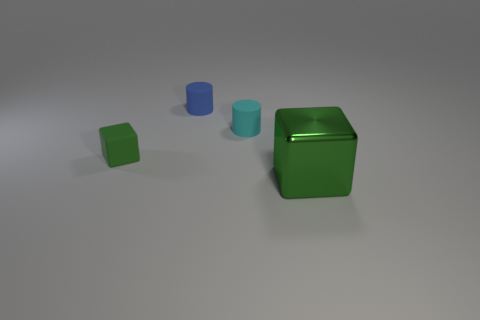There is a metallic object; is its color the same as the rubber cylinder that is on the left side of the tiny cyan cylinder?
Your response must be concise. No. What shape is the matte object in front of the cyan rubber cylinder?
Keep it short and to the point. Cube. How many other objects are there of the same material as the tiny green cube?
Your answer should be compact. 2. What material is the cyan cylinder?
Your answer should be very brief. Rubber. What number of small objects are green cubes or rubber cubes?
Provide a short and direct response. 1. What number of metallic cubes are behind the tiny green rubber cube?
Offer a terse response. 0. Are there any big matte things of the same color as the big block?
Give a very brief answer. No. What shape is the green matte object that is the same size as the cyan cylinder?
Give a very brief answer. Cube. What number of green objects are metal cylinders or tiny things?
Provide a succinct answer. 1. How many cylinders have the same size as the green metal object?
Your answer should be very brief. 0. 